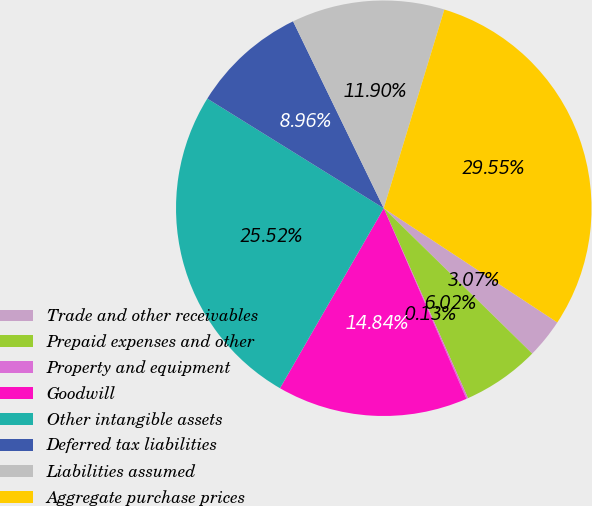Convert chart. <chart><loc_0><loc_0><loc_500><loc_500><pie_chart><fcel>Trade and other receivables<fcel>Prepaid expenses and other<fcel>Property and equipment<fcel>Goodwill<fcel>Other intangible assets<fcel>Deferred tax liabilities<fcel>Liabilities assumed<fcel>Aggregate purchase prices<nl><fcel>3.07%<fcel>6.02%<fcel>0.13%<fcel>14.84%<fcel>25.52%<fcel>8.96%<fcel>11.9%<fcel>29.55%<nl></chart> 